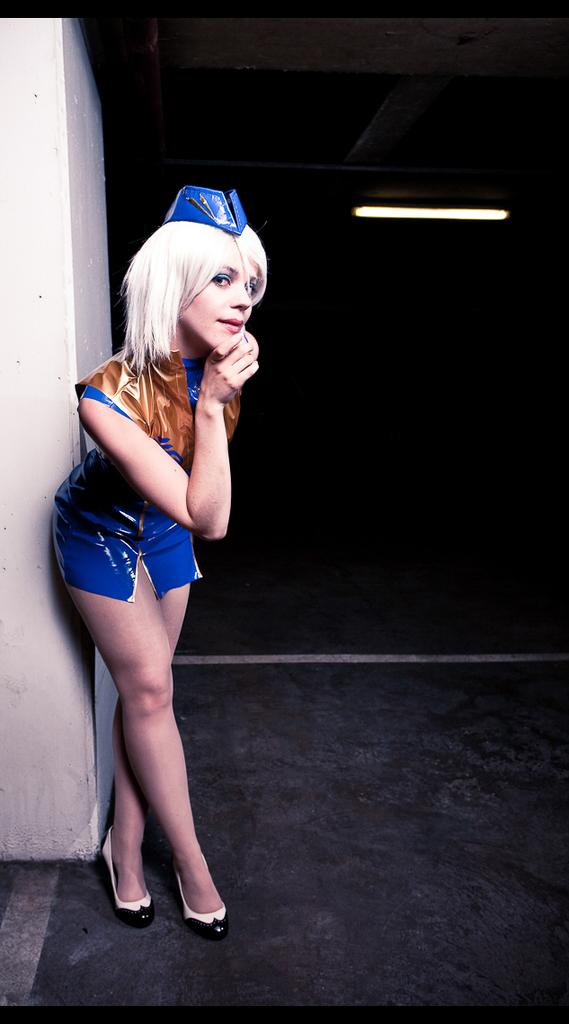What is the main subject in the foreground of the image? There is a woman standing in the foreground of the image. What can be seen in the background of the image? There is a wall and a light in the background of the image. What is the color of the background in the image? The background of the image is black. What is visible at the bottom of the image? There is a floor visible at the bottom of the image. What is the woman's income in the image? There is no information about the woman's income in the image. What type of fruit is the woman holding in the image? There is no fruit visible in the image. 